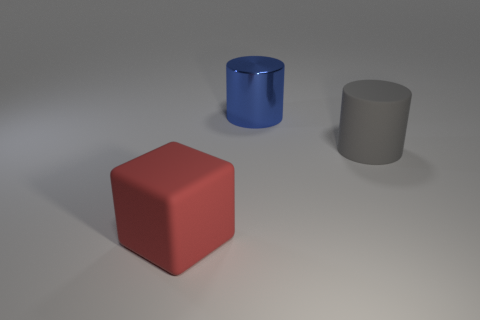The big matte cube has what color?
Offer a very short reply. Red. What material is the object that is behind the gray rubber thing?
Provide a succinct answer. Metal. Are there fewer large metallic objects behind the big metal object than gray cubes?
Your response must be concise. No. Are any large green blocks visible?
Keep it short and to the point. No. What is the color of the other matte thing that is the same shape as the big blue thing?
Provide a succinct answer. Gray. Do the matte cylinder and the block have the same size?
Your answer should be compact. Yes. The red object that is the same material as the gray cylinder is what shape?
Your answer should be compact. Cube. What number of other things are the same shape as the red thing?
Ensure brevity in your answer.  0. What shape is the big matte thing that is to the left of the object behind the big rubber object that is on the right side of the red thing?
Provide a short and direct response. Cube. How many spheres are large blue metal things or rubber things?
Offer a terse response. 0. 